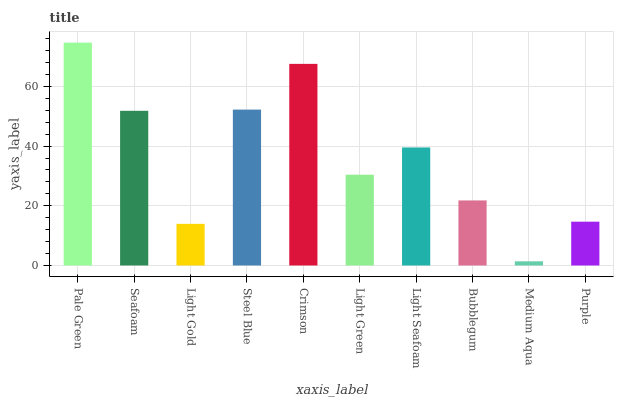Is Medium Aqua the minimum?
Answer yes or no. Yes. Is Pale Green the maximum?
Answer yes or no. Yes. Is Seafoam the minimum?
Answer yes or no. No. Is Seafoam the maximum?
Answer yes or no. No. Is Pale Green greater than Seafoam?
Answer yes or no. Yes. Is Seafoam less than Pale Green?
Answer yes or no. Yes. Is Seafoam greater than Pale Green?
Answer yes or no. No. Is Pale Green less than Seafoam?
Answer yes or no. No. Is Light Seafoam the high median?
Answer yes or no. Yes. Is Light Green the low median?
Answer yes or no. Yes. Is Steel Blue the high median?
Answer yes or no. No. Is Light Gold the low median?
Answer yes or no. No. 